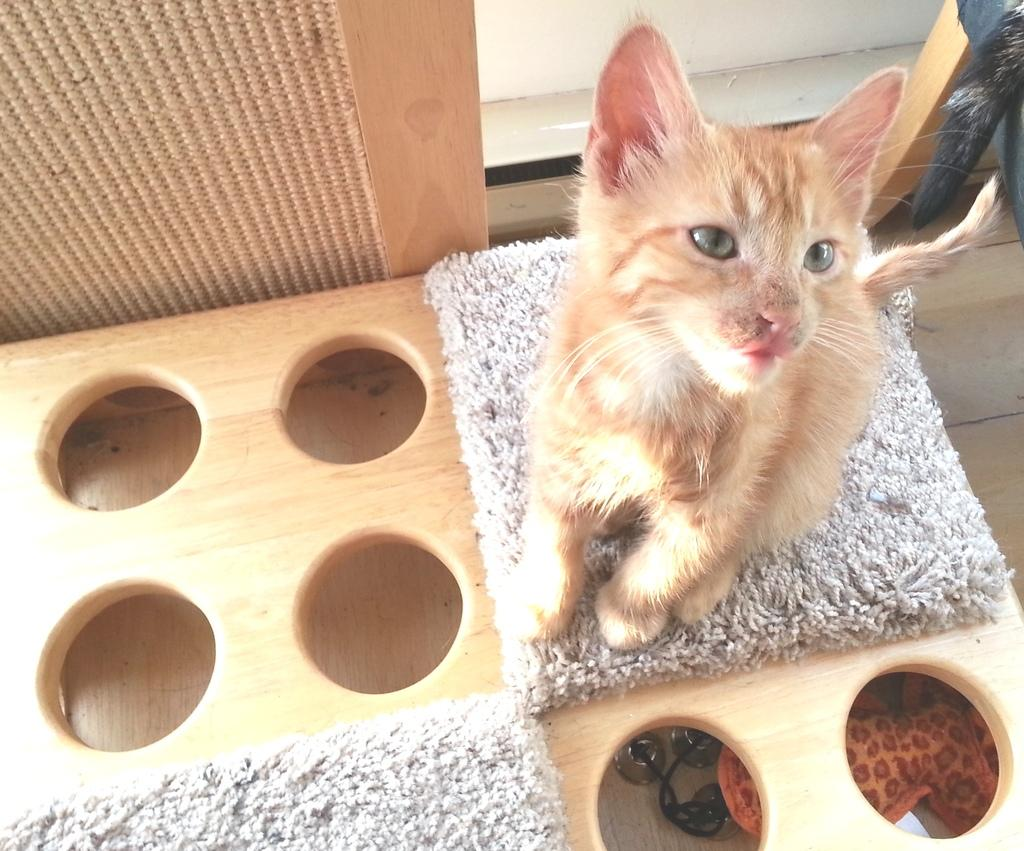What animal is present in the image? There is a cat in the image. What is the cat sitting on? The cat is on a white color mat. What is the color of the object beneath the mat? The mat is on a brown color object. Can you describe the surroundings of the cat? There are objects visible around the cat. How much money does the cat have in the image? There is no indication of money in the image, so it cannot be determined. 